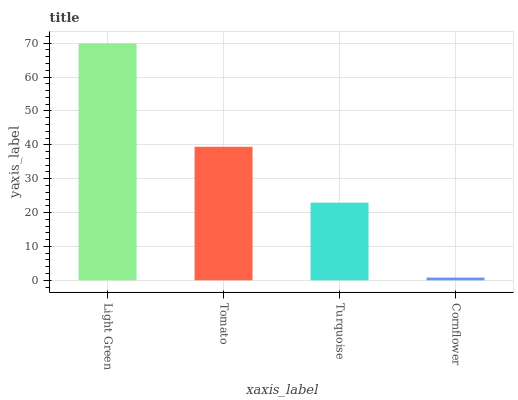Is Cornflower the minimum?
Answer yes or no. Yes. Is Light Green the maximum?
Answer yes or no. Yes. Is Tomato the minimum?
Answer yes or no. No. Is Tomato the maximum?
Answer yes or no. No. Is Light Green greater than Tomato?
Answer yes or no. Yes. Is Tomato less than Light Green?
Answer yes or no. Yes. Is Tomato greater than Light Green?
Answer yes or no. No. Is Light Green less than Tomato?
Answer yes or no. No. Is Tomato the high median?
Answer yes or no. Yes. Is Turquoise the low median?
Answer yes or no. Yes. Is Cornflower the high median?
Answer yes or no. No. Is Tomato the low median?
Answer yes or no. No. 